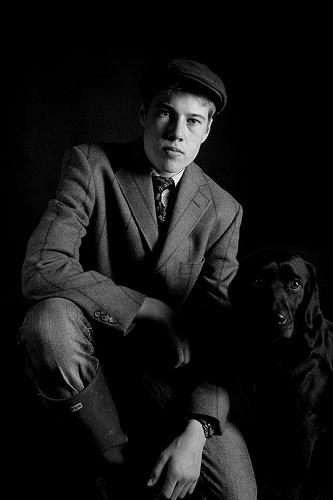Mention any detail about the dog's physical appearance in the image. The dog has black eyes and a long ear. Describe any visible feature on the person's face including facial accessories, if any. The man has a reflection on his nose, and he's wearing a necktie tilted to his right side. Mention the type and color of footwear the person is wearing in the image. The person in the image is wearing a tall black boot on their right foot. Identify the type of print present on the man's tie and any specific pattern or design. The man is wearing a tie with a floral print around his neck. Describe the person's outfit in the image along with any distinct features. The man is wearing a three-piece gray suit with a floral print tie and a sport coat with a stripe. Highlight a unique trait or feature of the person's hand. The person in the image has a feminine-looking hand. State the type of wrist accessory worn by the person in the image and which wrist it's on. The man is wearing a wristwatch on his left wrist. Use a single sentence to describe the overall theme of the image, including the main subjects. The image captures a moment of a man wearing a suit and a black hat, sitting together with a handsome black dog. Identify the head accessory worn by the person in the image and its color. The man is wearing a black cap on his head. Mention the two primary subjects in the image and how they are positioned in relation to each other. A man in a suit and a black dog are sitting together, with the dog positioned next to the man. 